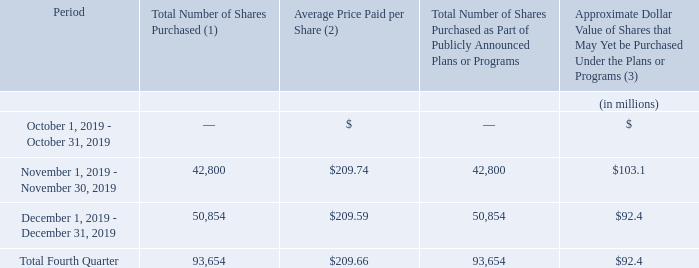Issuer Purchases of Equity Securities
In March 2011, our Board of Directors approved a stock repurchase program, pursuant to which we are authorized to repurchase up to $1.5 billion of our common stock (the “2011 Buyback”). In addition to the 2011 Buyback, in December 2017, our Board of Directors approved an additional stock repurchase program, pursuant to which we are authorized to repurchase up to $2.0 billion of our common stock (the “2017 Buyback”, and together with the 2011 Buyback the “Buyback Programs”).
During the three months ended December 31, 2019, we repurchased a total of 93,654 shares of our common stock for an aggregate of $19.6 million, including commissions and fees, pursuant to the 2011 Buyback. There were no repurchases under the 2017 Buyback. The table below sets forth details of our repurchases under the 2011 Buyback during the three months ended December 31, 2019.
(1) Repurchases made pursuant to the 2011 Buyback
(2) Average price paid per share is a weighted average calculation using the aggregate price, excluding commissions and fees.
(3) Remaining under the 2011 Buyback.
We have repurchased a total of 14.1 million shares of our common stock under the 2011 Buyback for an aggregate of $1.4 billion, including commissions and fees. We expect to continue to manage the pacing of the remaining $2.1 billion under the Buyback Programs in response to general market conditions and other relevant factors. We expect to fund any further repurchases of our common stock through a combination of cash on hand, cash generated by operations and borrowings under our credit facilities. Purchases under the Buyback Programs are subject to our having available cash to fund repurchases.
Under the Buyback Programs, our management is authorized to purchase shares from time to time through open market purchases or in privately negotiated transactions not to exceed market prices and subject to market conditions and other factors. With respect to open market purchases, we may use plans adopted in accordance with Rule 10b5-1 under the Exchange Act in accordance with securities laws and other legal requirements, which allows us to repurchase shares during periods when we otherwise might be prevented from doing so under insider trading laws or because of self-imposed trading blackout periods. These programs may be discontinued at any time.
What do the company's Buyback Programs authorize the company to do? Management is authorized to purchase shares from time to time through open market purchases or in privately negotiated transactions not to exceed market prices and subject to market conditions and other factors. During the fourth quarter 2019, how many shares of their common stock did the company purchase? 93,654. How many shares were purchased in November? 42,800. What is the average of average price paid per share between November and December? ($209.74+$209.59)/2
Answer: 209.67. What was the change in the total number of shares purchased between November and December?
Answer scale should be: million. 50,854-42,800
Answer: 8054. What was the percentage change in the Approximate Dollar Value of Shares that May Yet be Purchased Under the Plans or Programs between November and December?
Answer scale should be: percent. ($92.4-$103.1)/$103.1
Answer: -10.38. 